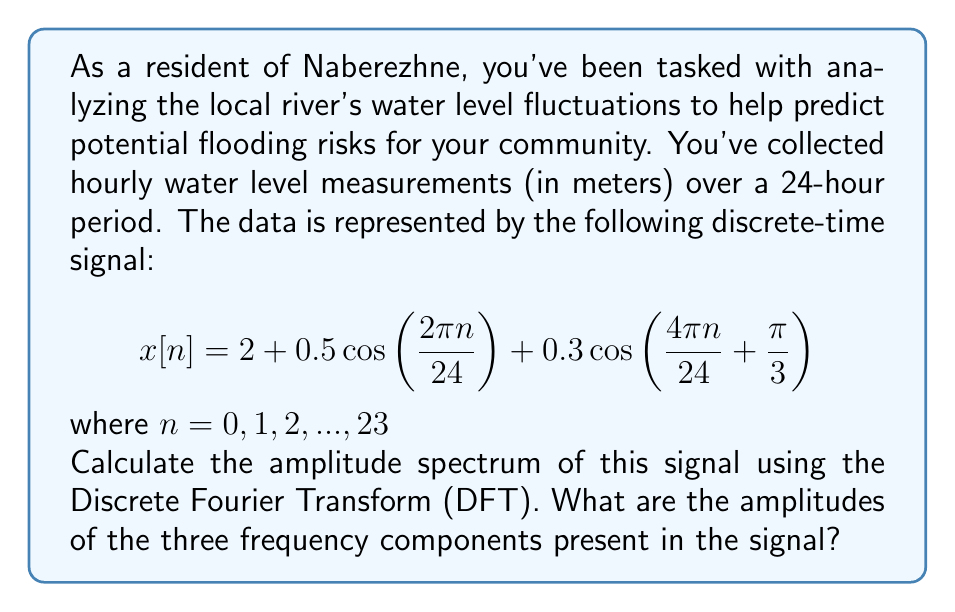Provide a solution to this math problem. Let's approach this step-by-step:

1) The given signal has three components:
   - A DC component (constant term): 2
   - Two cosine terms with different frequencies and phases

2) To find the amplitude spectrum, we need to calculate the DFT of the signal. The DFT is given by:

   $$X[k] = \sum_{n=0}^{N-1} x[n]e^{-j2\pi kn/N}$$

   where $N = 24$ (the number of samples)

3) For the DC component:
   $X[0] = 2 * 24 = 48$ (sum of the constant term over 24 samples)

4) For the first cosine term:
   $0.5\cos(2\pi n/24)$ has a frequency of 1 cycle per 24 samples, so it will appear at $k=1$ in the DFT.
   Its amplitude in the DFT will be: $0.5 * N/2 = 0.5 * 24/2 = 6$

5) For the second cosine term:
   $0.3\cos(4\pi n/24 + \pi/3)$ has a frequency of 2 cycles per 24 samples, so it will appear at $k=2$ in the DFT.
   Its amplitude in the DFT will be: $0.3 * N/2 = 0.3 * 24/2 = 3.6$

6) To get the actual amplitudes, we need to divide the DFT values by $N$:
   - DC component: 48 / 24 = 2
   - First cosine: 6 / 24 = 0.5
   - Second cosine: 3.6 / 24 = 0.15

Note: The phase of the second cosine doesn't affect its amplitude in the spectrum.
Answer: 2, 0.5, 0.15 